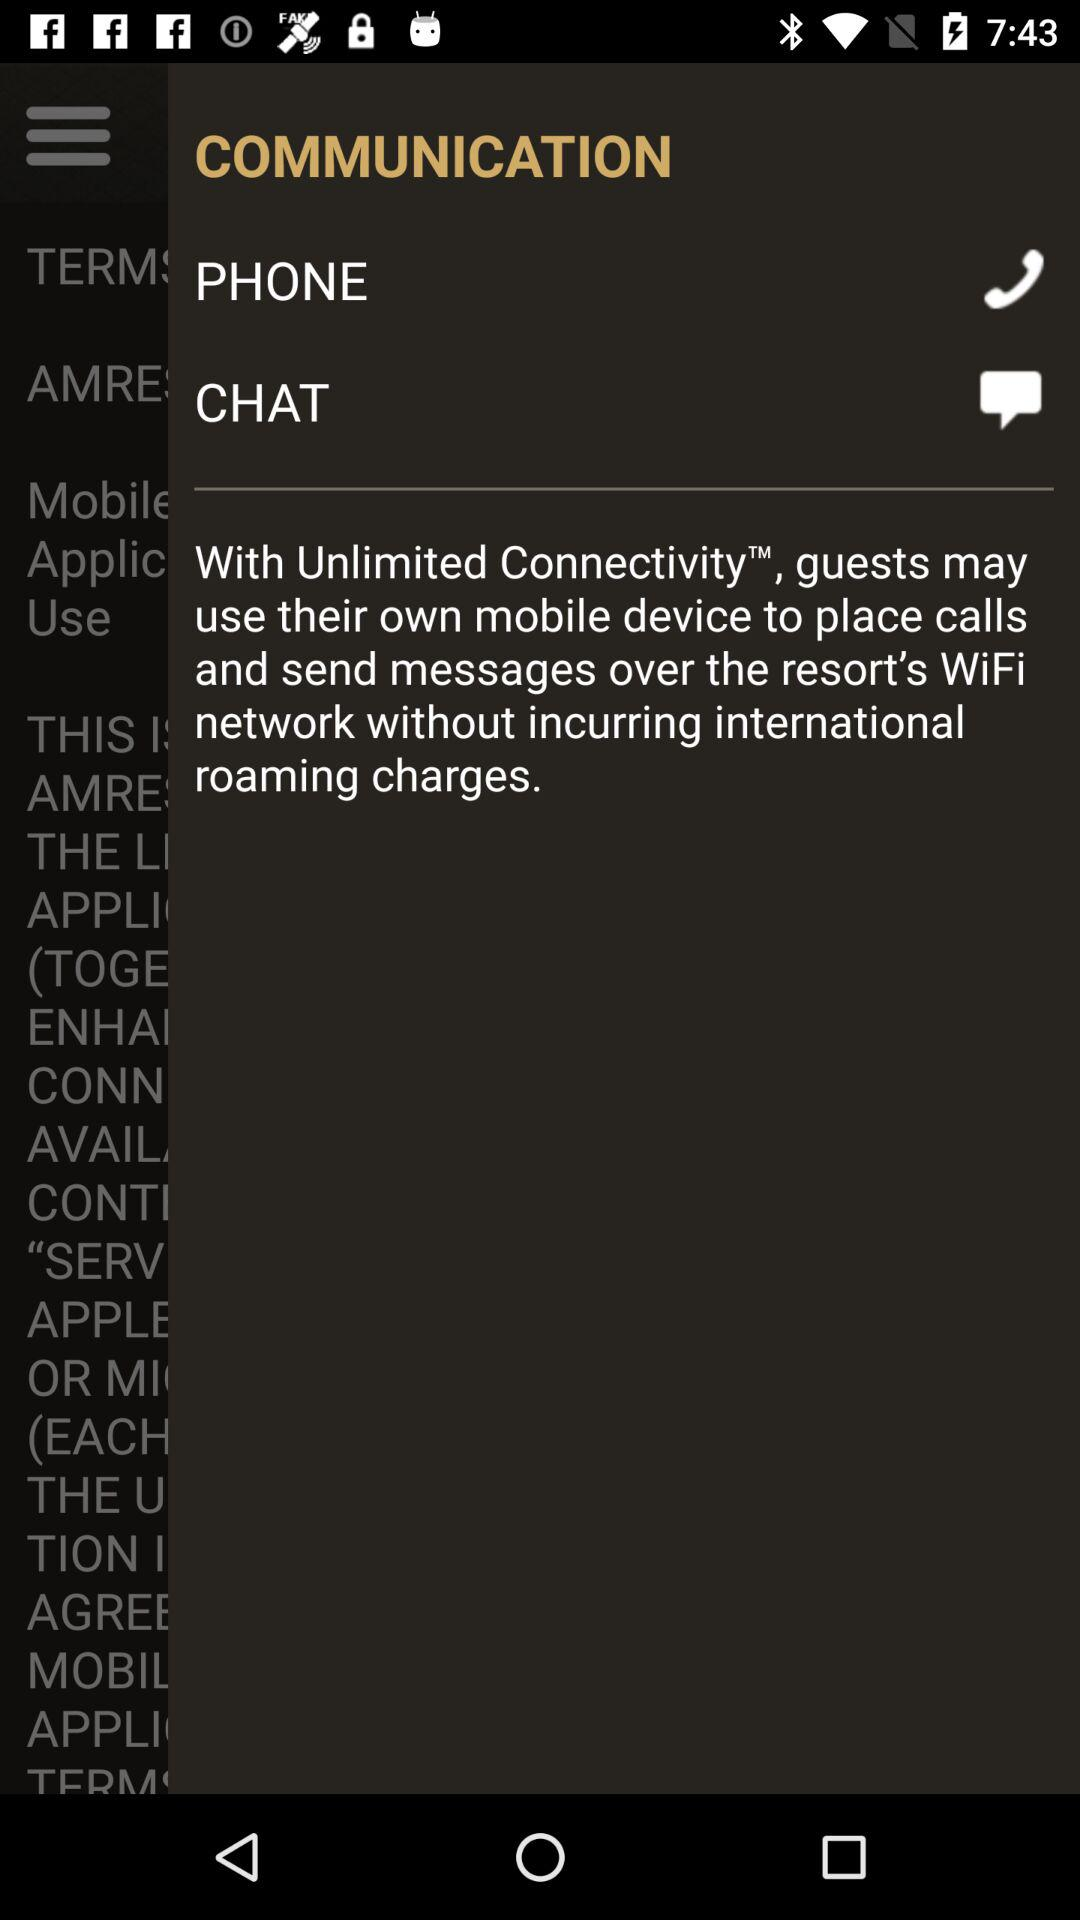What kind of connectivity is available at the resort? The kind of connectivity that is available at the resort is "Unlimited Connectivity". 